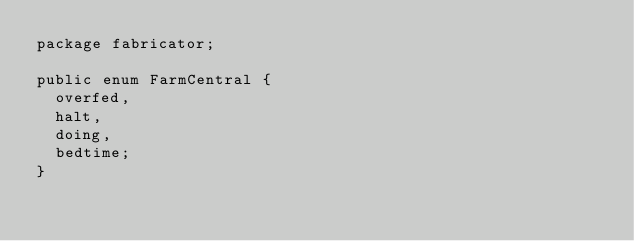<code> <loc_0><loc_0><loc_500><loc_500><_Java_>package fabricator;

public enum FarmCentral {
  overfed,
  halt,
  doing,
  bedtime;
}
</code> 